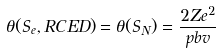Convert formula to latex. <formula><loc_0><loc_0><loc_500><loc_500>\theta ( S _ { e } , R C E D ) = \theta ( S _ { N } ) = \frac { 2 Z e ^ { 2 } } { p b v }</formula> 